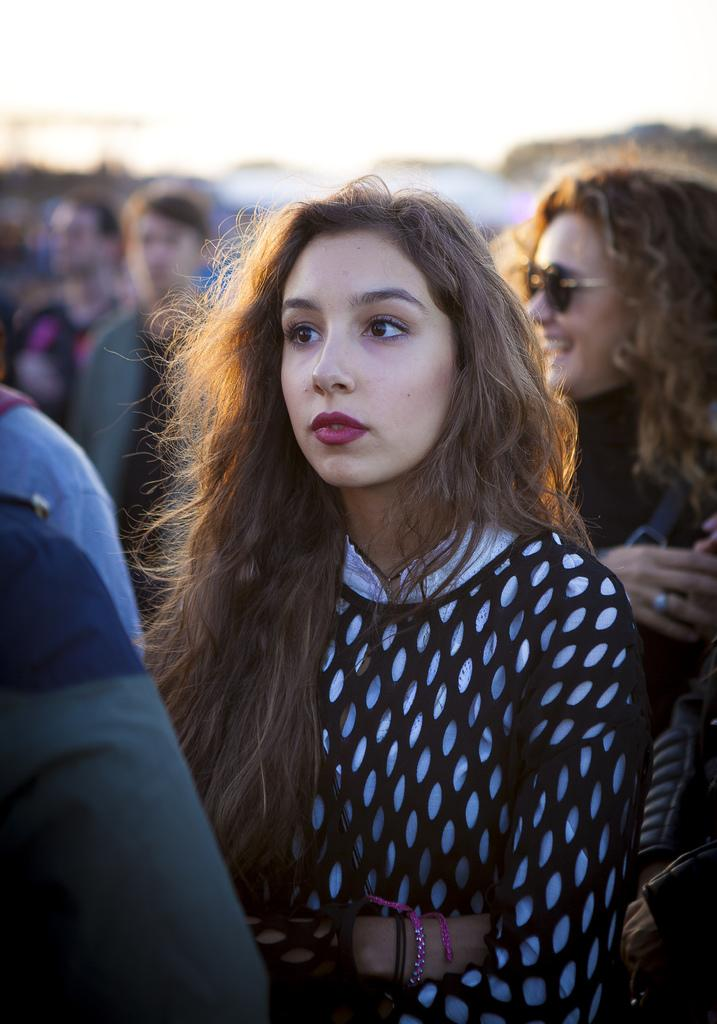Who is the main subject in the image? There is a woman in the image. What is the woman wearing? The woman is wearing a black and white dress. Can you describe the background of the image? The background of the image is slightly blurred. Are there any other people visible in the image? Yes, there are a few more people visible in the background. What type of bird can be seen flying in the image? There is no bird visible in the image. Can you describe the woman's kick in the image? There is no kick or any indication of physical activity in the image. 